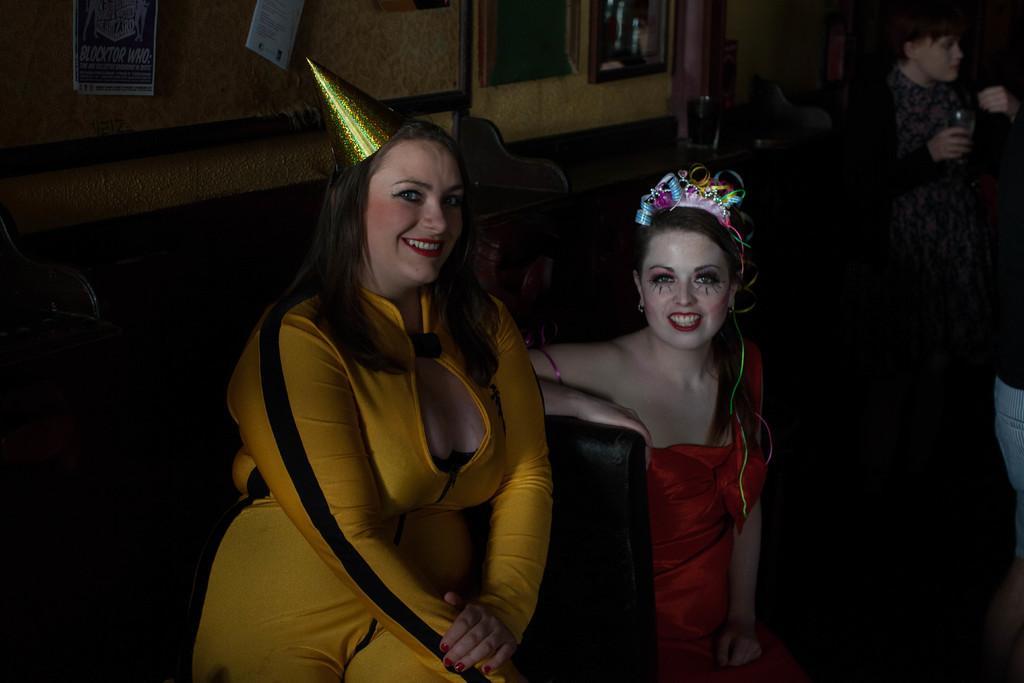Describe this image in one or two sentences. In this image two girls sitting with a smile on their face, beside them there is a person standing and holding a glass. In the background there are few frames and posters are hanging on the wall. 